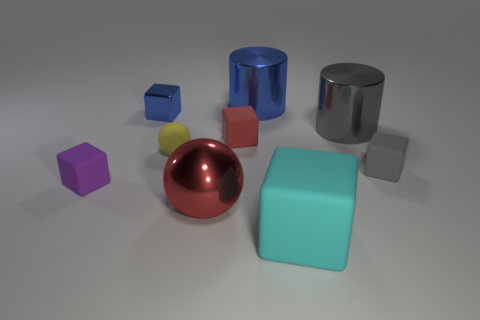Subtract all blue metal blocks. How many blocks are left? 4 Subtract all blue cubes. How many cubes are left? 4 Subtract all cylinders. How many objects are left? 7 Subtract 1 cylinders. How many cylinders are left? 1 Add 6 red blocks. How many red blocks are left? 7 Add 6 big red metal objects. How many big red metal objects exist? 7 Subtract 1 gray cylinders. How many objects are left? 8 Subtract all gray blocks. Subtract all purple cylinders. How many blocks are left? 4 Subtract all red cubes. How many red spheres are left? 1 Subtract all rubber spheres. Subtract all purple cubes. How many objects are left? 7 